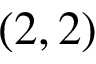<formula> <loc_0><loc_0><loc_500><loc_500>( 2 , 2 )</formula> 